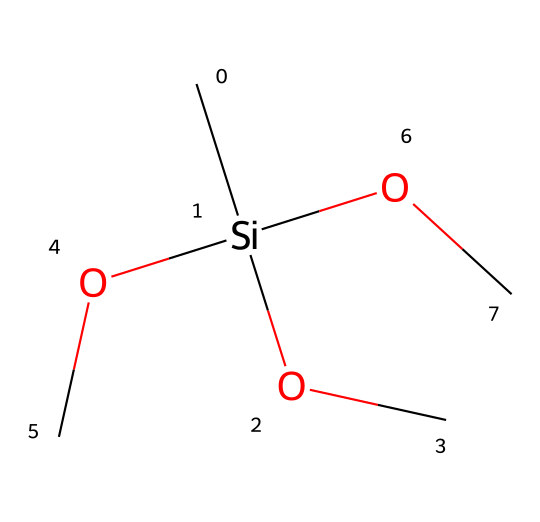What is the name of this silane compound? The SMILES representation indicates that the compound consists of a silicon atom bonded to three methoxy groups (OC) and one methyl group (C). This corresponds to the structure of methyltrimethoxysilane.
Answer: methyltrimethoxysilane How many oxygen atoms are present in this molecule? The structure includes three methoxy groups (each has one oxygen), contributing to a total of three oxygen atoms in the molecule.
Answer: 3 What type of bonds are present between the silicon atom and the surrounding atoms? In the given structure, the silicon atom forms single covalent bonds with three oxygen atoms and one carbon atom, characteristic of silanes.
Answer: single bonds What functional groups are found in this chemical? The molecule contains methoxy groups (–OCH3), which are functional groups that provide its distinct chemical characteristics, in addition to a methyl group (–CH3).
Answer: methoxy and methyl groups Why does methyltrimethoxysilane enhance water repellency? The molecular structure of methyltrimethoxysilane allows it to form a hydrophobic layer due to the presence of nonpolar methyl groups, which effectively repels water.
Answer: hydrophobic layer What is the hybridization of the silicon atom in this compound? The silicon atom is bonded to four groups (three methoxy groups and one methyl group), indicating an sp3 hybridization due to the tetrahedral arrangement of the bonds.
Answer: sp3 hybridization 